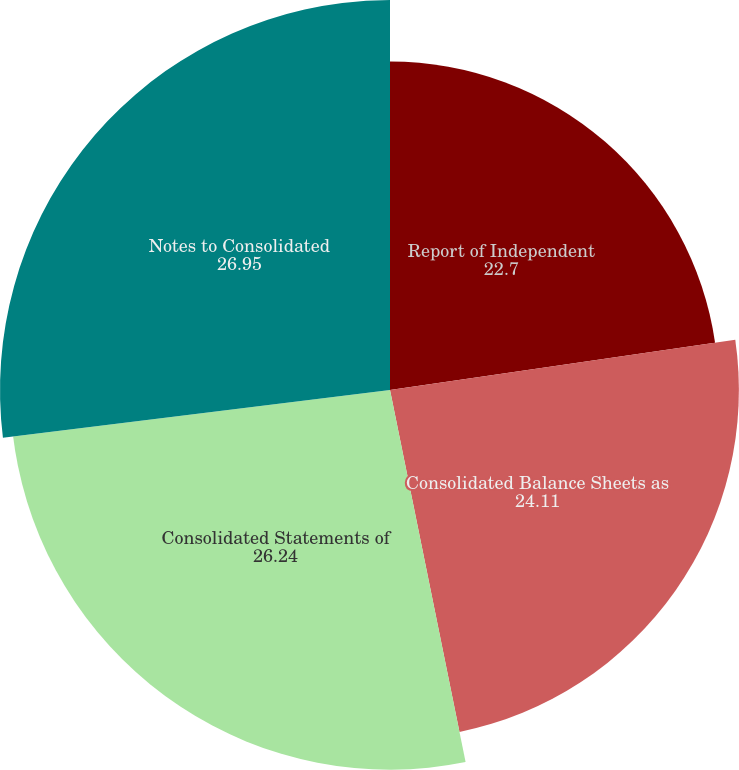Convert chart to OTSL. <chart><loc_0><loc_0><loc_500><loc_500><pie_chart><fcel>Report of Independent<fcel>Consolidated Balance Sheets as<fcel>Consolidated Statements of<fcel>Notes to Consolidated<nl><fcel>22.7%<fcel>24.11%<fcel>26.24%<fcel>26.95%<nl></chart> 